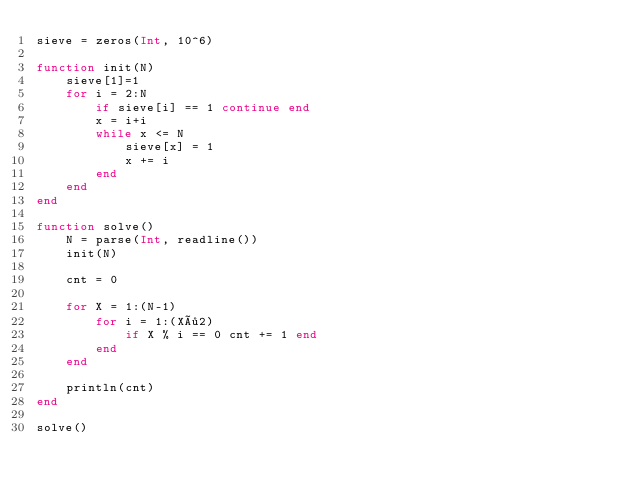<code> <loc_0><loc_0><loc_500><loc_500><_Julia_>sieve = zeros(Int, 10^6)

function init(N)
    sieve[1]=1
    for i = 2:N
        if sieve[i] == 1 continue end
        x = i+i
        while x <= N
            sieve[x] = 1
            x += i
        end
    end
end

function solve()
    N = parse(Int, readline())
    init(N)

    cnt = 0

    for X = 1:(N-1)
        for i = 1:(X÷2)
            if X % i == 0 cnt += 1 end
        end
    end

    println(cnt)
end

solve()
</code> 